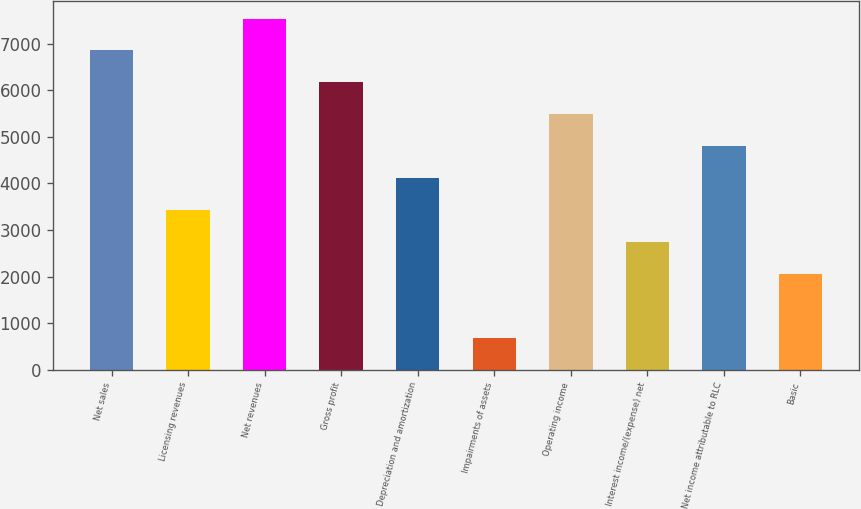Convert chart to OTSL. <chart><loc_0><loc_0><loc_500><loc_500><bar_chart><fcel>Net sales<fcel>Licensing revenues<fcel>Net revenues<fcel>Gross profit<fcel>Depreciation and amortization<fcel>Impairments of assets<fcel>Operating income<fcel>Interest income/(expense) net<fcel>Net income attributable to RLC<fcel>Basic<nl><fcel>6859.5<fcel>3430.15<fcel>7545.37<fcel>6173.63<fcel>4116.02<fcel>686.67<fcel>5487.76<fcel>2744.28<fcel>4801.89<fcel>2058.41<nl></chart> 